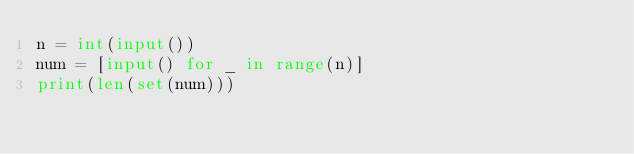Convert code to text. <code><loc_0><loc_0><loc_500><loc_500><_Python_>n = int(input())
num = [input() for _ in range(n)]
print(len(set(num)))</code> 